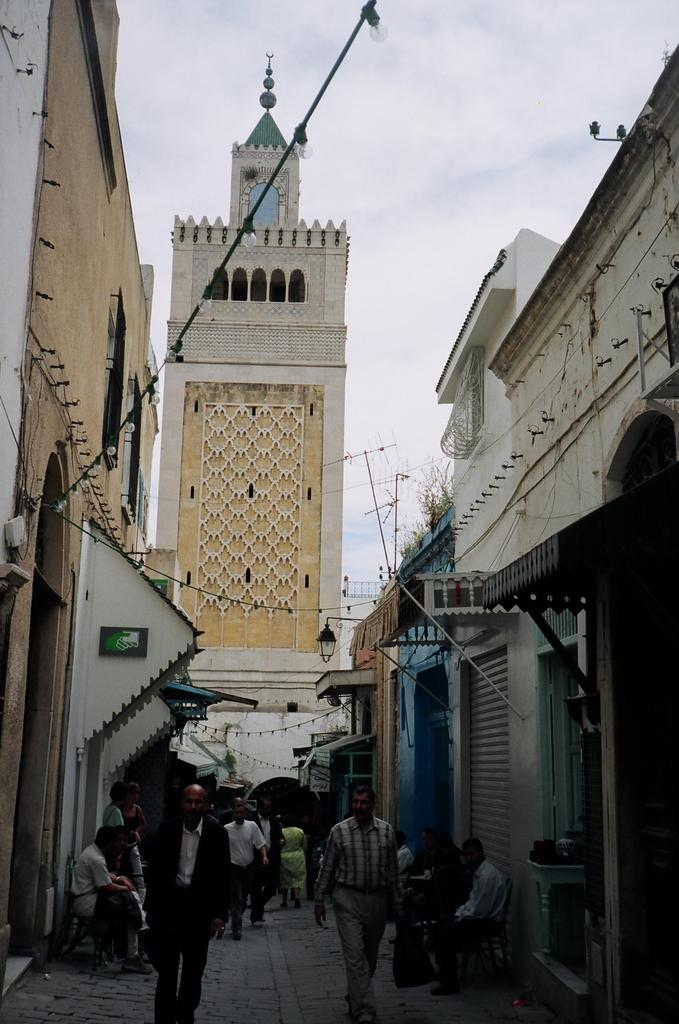What are the people in the image doing? There are people sitting and walking in the image. What can be seen illuminated in the image? There are lights visible in the image. What type of structure is present in the image? There is a wall, buildings, and a tower in the image. What is visible in the background of the image? The sky is visible in the background of the image. What type of blood is visible on the bulb in the image? There is no blood or bulb present in the image. What color is the van parked near the tower in the image? There is no van present in the image; only people, lights, a wall, buildings, and a tower are visible. 